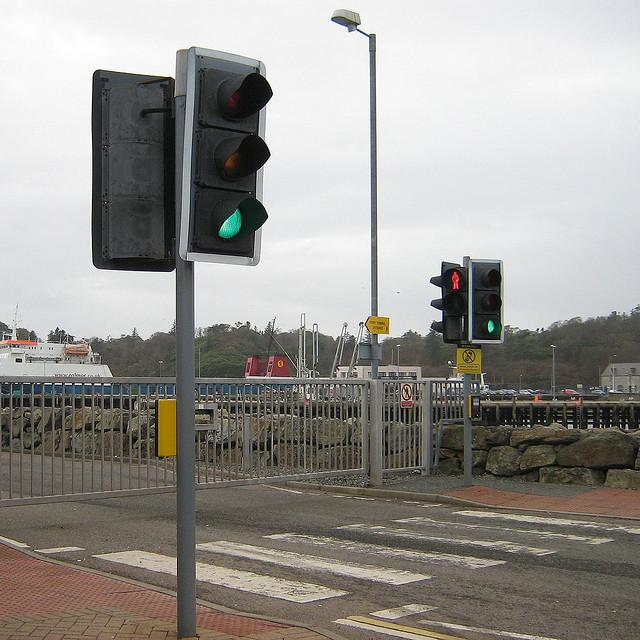What type of surface can be found past the rock wall to the right of the road?

Choices:
A) gravel
B) water
C) sand
D) grass water 